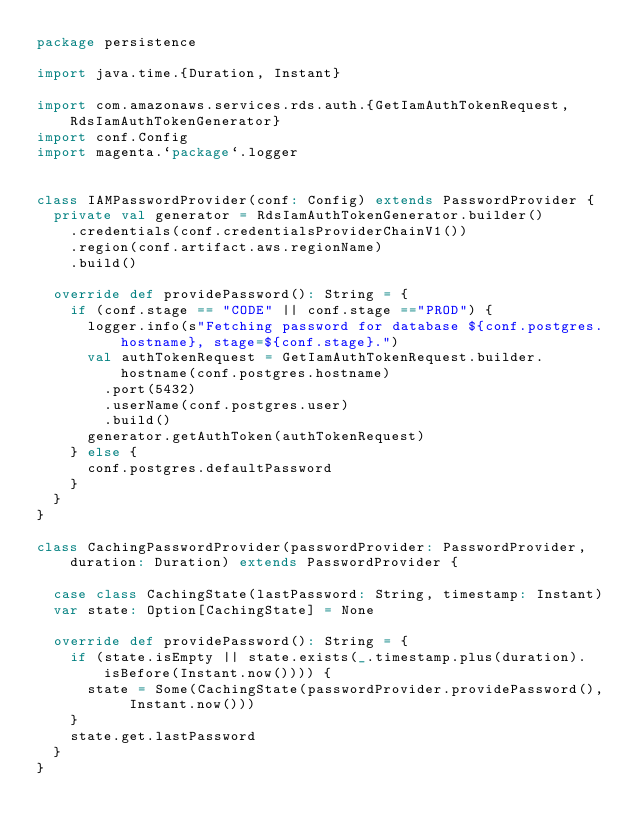<code> <loc_0><loc_0><loc_500><loc_500><_Scala_>package persistence

import java.time.{Duration, Instant}

import com.amazonaws.services.rds.auth.{GetIamAuthTokenRequest, RdsIamAuthTokenGenerator}
import conf.Config
import magenta.`package`.logger


class IAMPasswordProvider(conf: Config) extends PasswordProvider {
  private val generator = RdsIamAuthTokenGenerator.builder()
    .credentials(conf.credentialsProviderChainV1())
    .region(conf.artifact.aws.regionName)
    .build()

  override def providePassword(): String = {
    if (conf.stage == "CODE" || conf.stage =="PROD") {
      logger.info(s"Fetching password for database ${conf.postgres.hostname}, stage=${conf.stage}.")
      val authTokenRequest = GetIamAuthTokenRequest.builder.hostname(conf.postgres.hostname)
        .port(5432)
        .userName(conf.postgres.user)
        .build()
      generator.getAuthToken(authTokenRequest)
    } else {
      conf.postgres.defaultPassword
    }
  }
}

class CachingPasswordProvider(passwordProvider: PasswordProvider, duration: Duration) extends PasswordProvider {

  case class CachingState(lastPassword: String, timestamp: Instant)
  var state: Option[CachingState] = None

  override def providePassword(): String = {
    if (state.isEmpty || state.exists(_.timestamp.plus(duration).isBefore(Instant.now()))) {
      state = Some(CachingState(passwordProvider.providePassword(), Instant.now()))
    }
    state.get.lastPassword
  }
}
</code> 